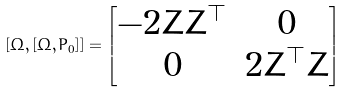Convert formula to latex. <formula><loc_0><loc_0><loc_500><loc_500>[ \Omega , [ \Omega , P _ { 0 } ] ] = \begin{bmatrix} - 2 Z Z ^ { \top } & 0 \\ 0 & 2 Z ^ { \top } Z \end{bmatrix}</formula> 